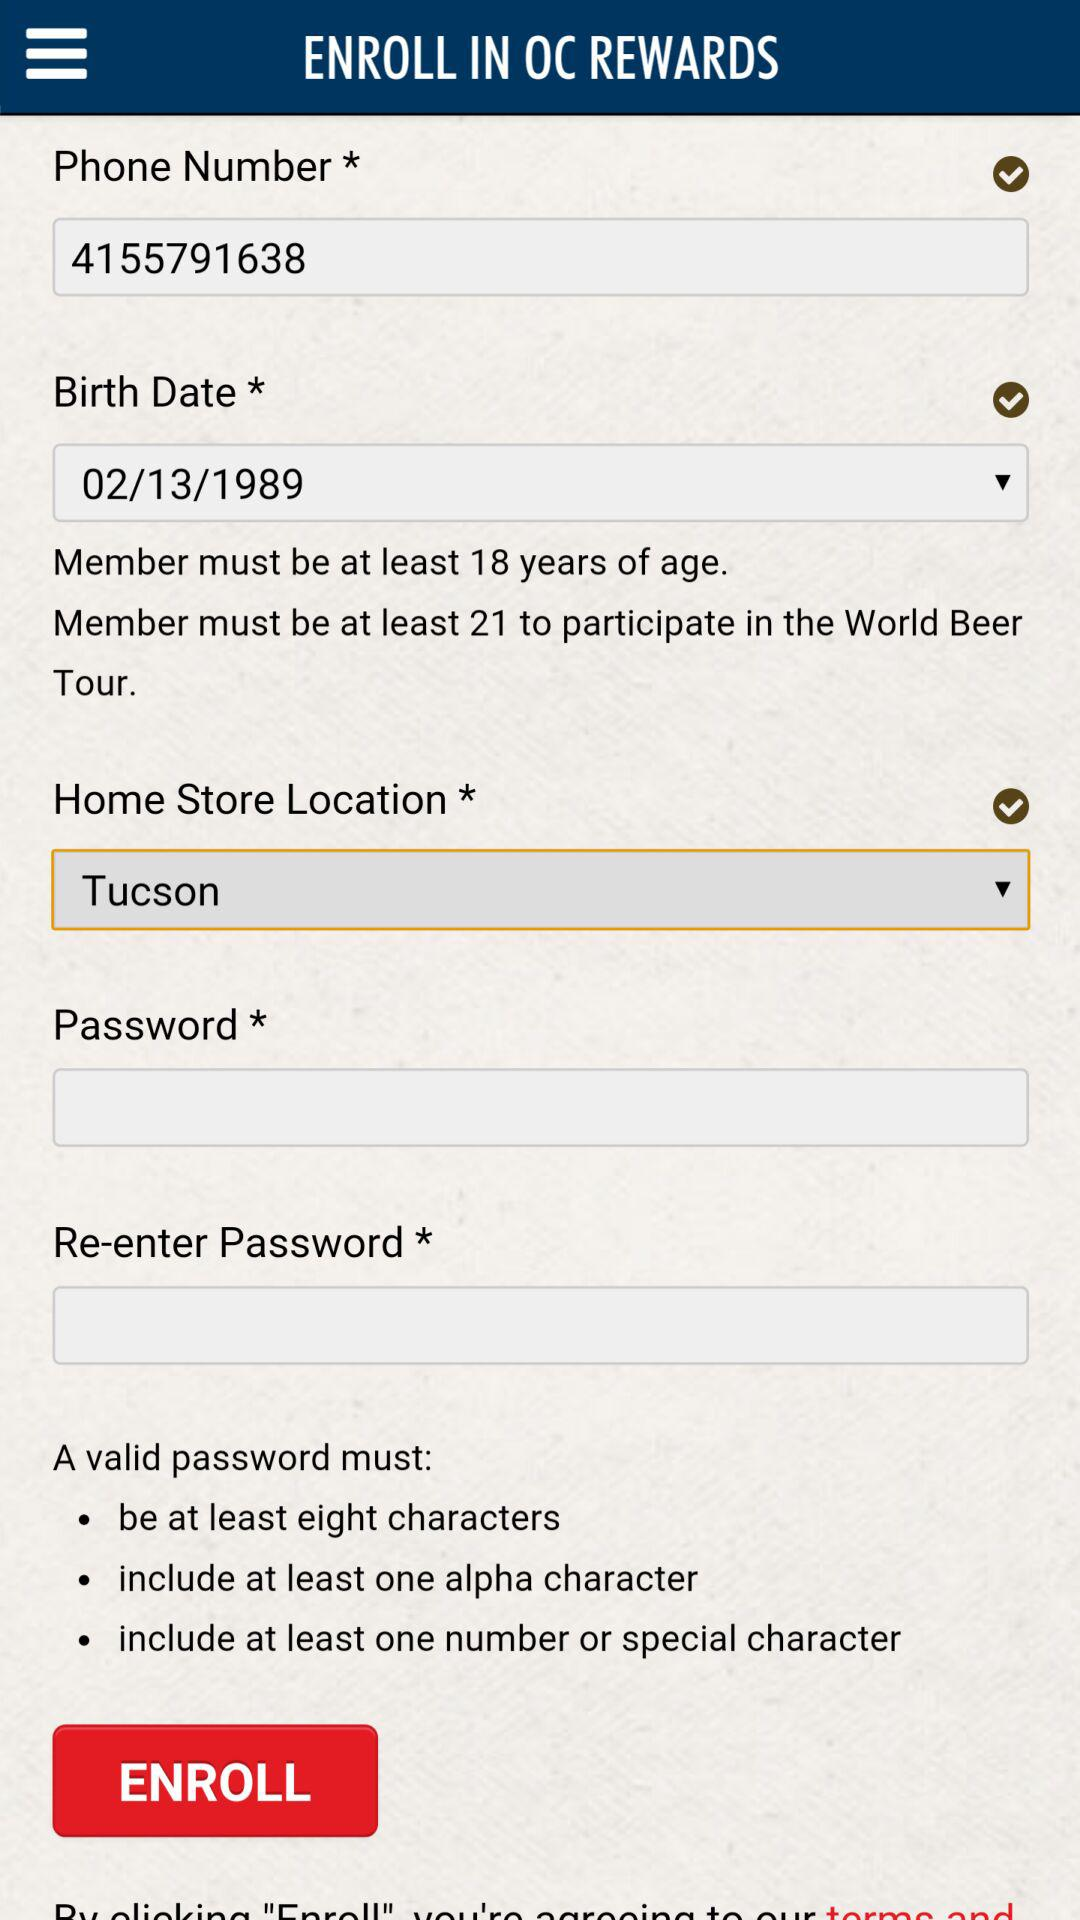What is the age limit to enroll in OC REWARDS? The age limit to enroll in OC REWARDS is 18 years old. 